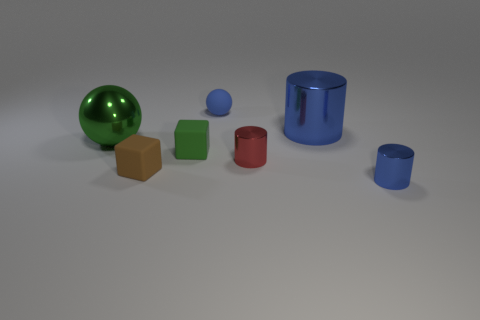Add 1 tiny red spheres. How many objects exist? 8 Subtract all cylinders. How many objects are left? 4 Subtract all tiny blue rubber things. Subtract all tiny matte cubes. How many objects are left? 4 Add 3 large blue cylinders. How many large blue cylinders are left? 4 Add 4 gray metal cylinders. How many gray metal cylinders exist? 4 Subtract 0 yellow balls. How many objects are left? 7 